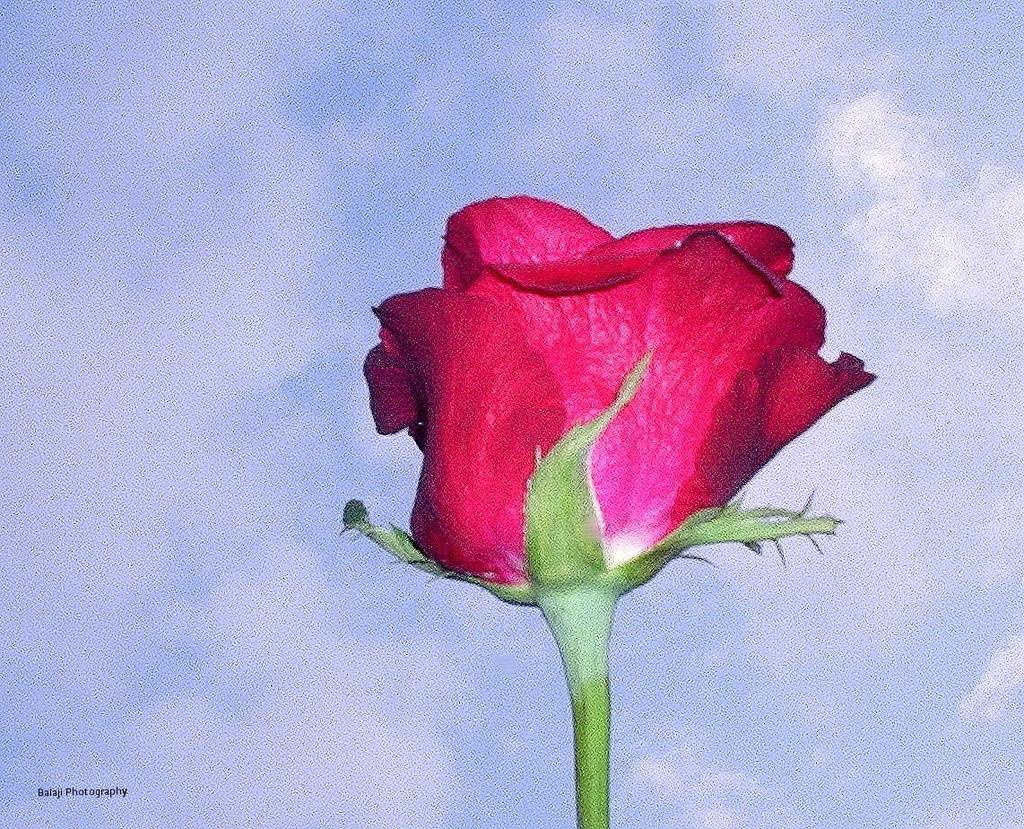What is depicted in the painting in the image? There is a painting of a rose flower in the image. What can be seen in the background of the image? There are clouds in the sky in the background of the image. What color is the magic stomach in the image? There is no mention of magic or a stomach in the image; it features a painting of a rose flower and clouds in the sky. 